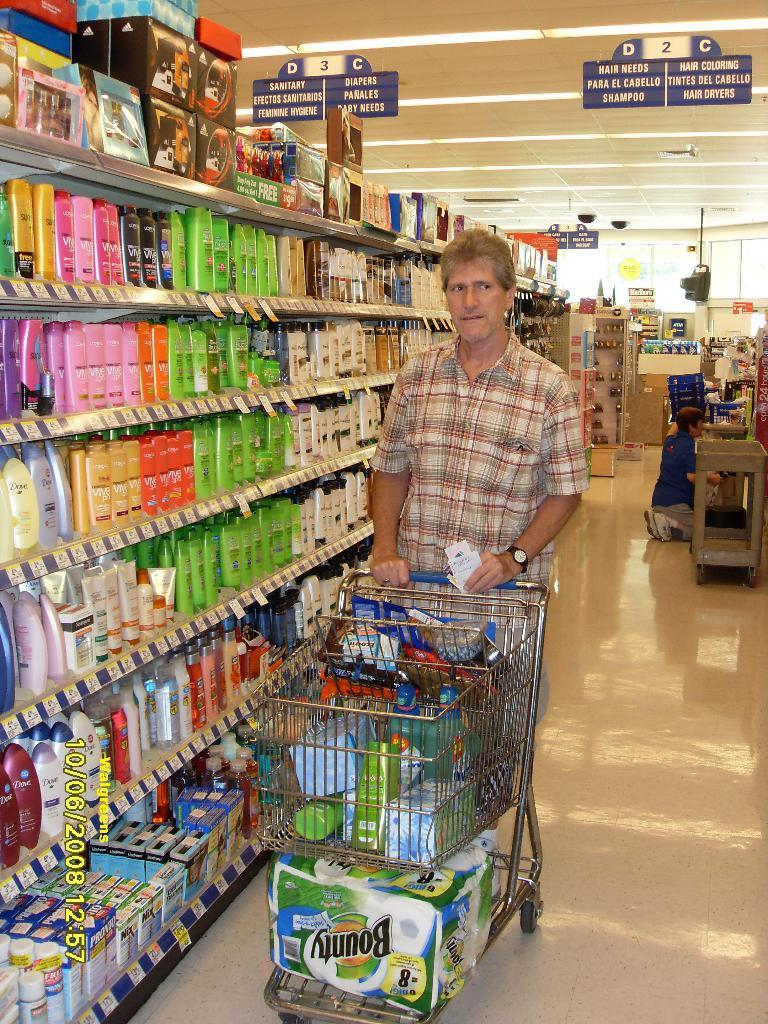<image>
Share a concise interpretation of the image provided. A man is shopping in Aisle D, at the Shampoo and hair products section. 